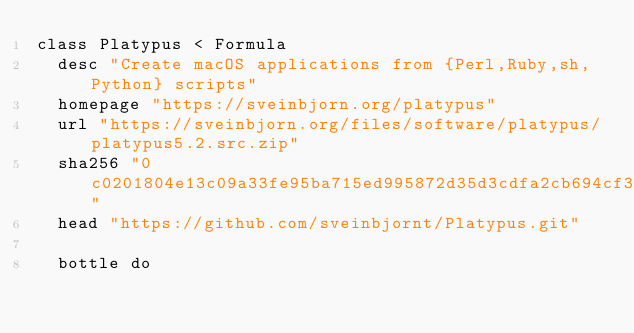Convert code to text. <code><loc_0><loc_0><loc_500><loc_500><_Ruby_>class Platypus < Formula
  desc "Create macOS applications from {Perl,Ruby,sh,Python} scripts"
  homepage "https://sveinbjorn.org/platypus"
  url "https://sveinbjorn.org/files/software/platypus/platypus5.2.src.zip"
  sha256 "0c0201804e13c09a33fe95ba715ed995872d35d3cdfa2cb694cf378980ed4c08"
  head "https://github.com/sveinbjornt/Platypus.git"

  bottle do</code> 